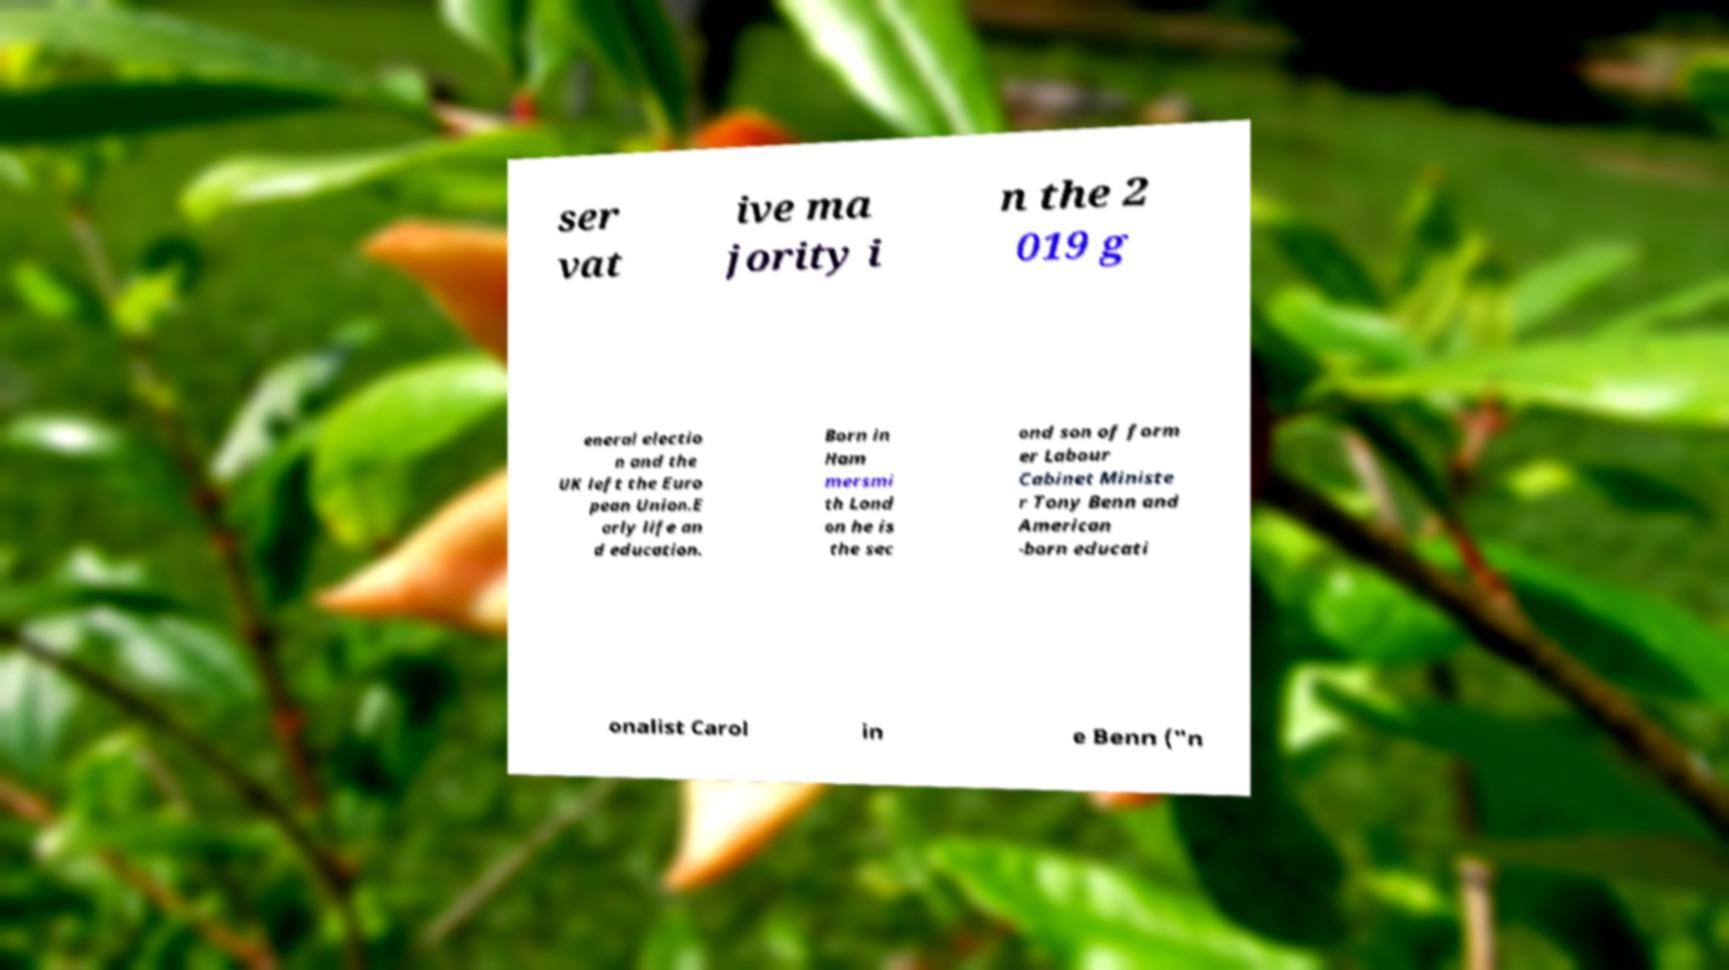Please read and relay the text visible in this image. What does it say? ser vat ive ma jority i n the 2 019 g eneral electio n and the UK left the Euro pean Union.E arly life an d education. Born in Ham mersmi th Lond on he is the sec ond son of form er Labour Cabinet Ministe r Tony Benn and American -born educati onalist Carol in e Benn ("n 